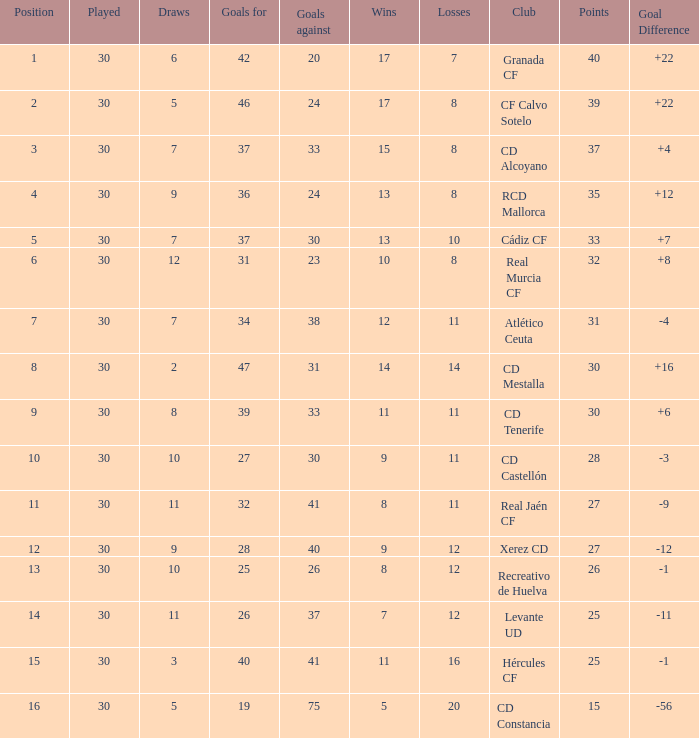How many Wins have Goals against smaller than 30, and Goals for larger than 25, and Draws larger than 5? 3.0. 